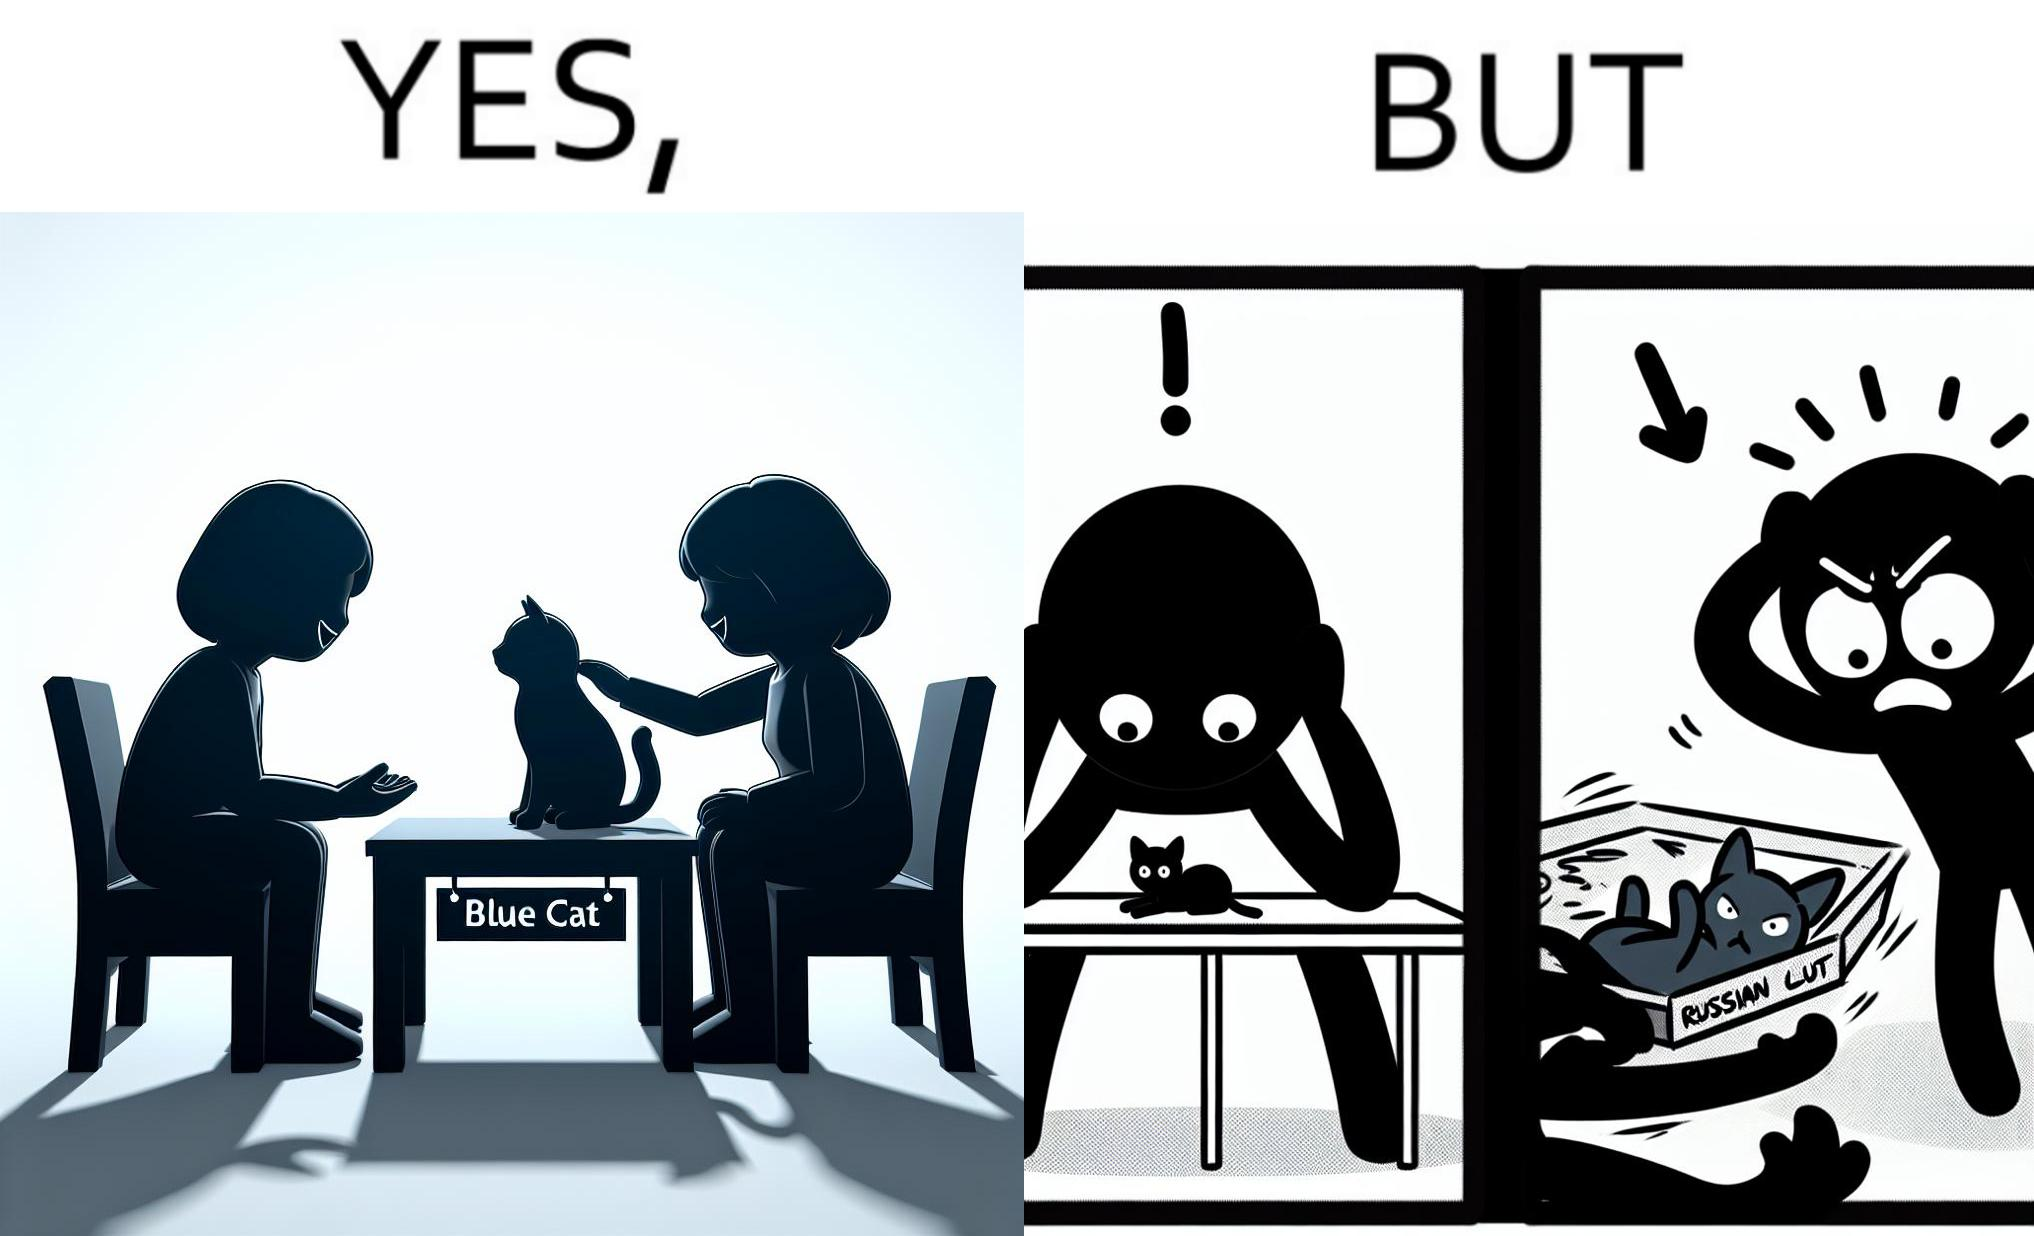Provide a description of this image. The image is confusing, as initially, when the label reads "Blue Cat", the people are happy and are petting tha cat, but as soon as one of them realizes that the entire text reads "Russian Blue Cat", they seem to worried, and one of them throws away the cat. For some reason, the word "Russian" is a trigger word for them. 